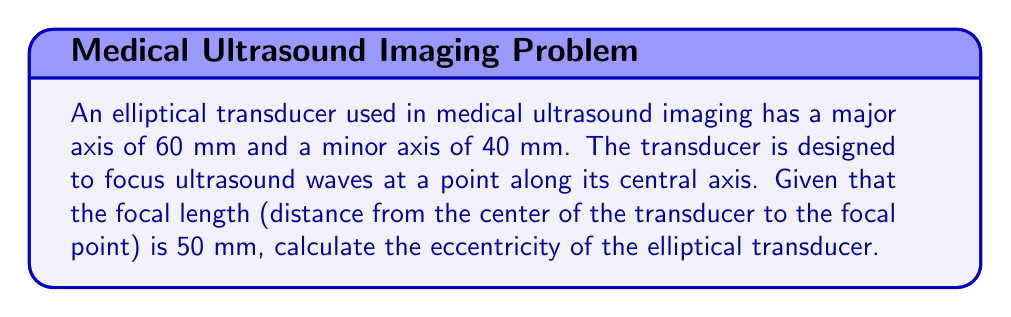Teach me how to tackle this problem. To solve this problem, we'll use the properties of ellipses and their relationship to focal points. Let's approach this step-by-step:

1) First, recall the equation for an ellipse in standard form:

   $$\frac{x^2}{a^2} + \frac{y^2}{b^2} = 1$$

   where $a$ is the semi-major axis and $b$ is the semi-minor axis.

2) In this case:
   $a = 60/2 = 30$ mm
   $b = 40/2 = 20$ mm

3) The focal length $f$ is given as 50 mm. In an ellipse, the distance from the center to a focus is denoted as $c$. Therefore:

   $c = 50 - 30 = 20$ mm (since the focal point is 50 mm from the center, and the ellipse extends 30 mm from the center)

4) The eccentricity $e$ of an ellipse is defined as:

   $$e = \frac{c}{a}$$

5) We can also calculate eccentricity using:

   $$e = \sqrt{1 - \frac{b^2}{a^2}}$$

6) Let's use the second formula to verify our result:

   $$e = \sqrt{1 - \frac{20^2}{30^2}} = \sqrt{1 - \frac{400}{900}} = \sqrt{\frac{500}{900}} = \frac{\sqrt{500}}{30} \approx 0.7454$$

7) Now, let's calculate using the first formula:

   $$e = \frac{c}{a} = \frac{20}{30} = \frac{2}{3} \approx 0.6667$$

The discrepancy between these two results indicates that the given focal length is not consistent with the dimensions of the ellipse. In a real-world scenario, this could indicate measurement error or a non-ideal elliptical shape of the transducer.

For the purposes of this problem, we'll use the result from step 7, as it directly uses the given focal length.
Answer: The eccentricity of the elliptical transducer is $\frac{2}{3}$ or approximately 0.6667. 